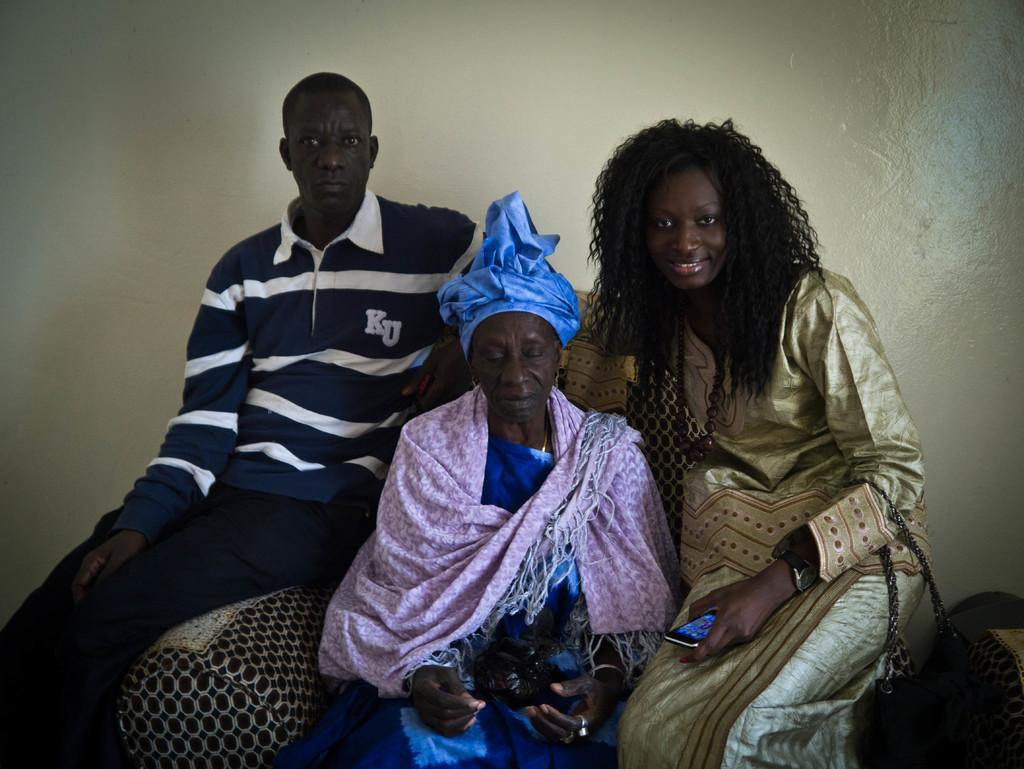How many people are in the image? There are three people in the image. Can you describe the gender of the people? Two of the people are women, and one is a man. What are the people doing in the image? The people are sitting on a sofa chair. What can be seen behind the people? There is a white wall behind them. Where was the image taken? The image was taken inside a room. What type of chicken is sitting on the man's tongue in the image? There is no chicken or tongue present in the image; it features three people sitting on a sofa chair in a room with a white wall behind them. 